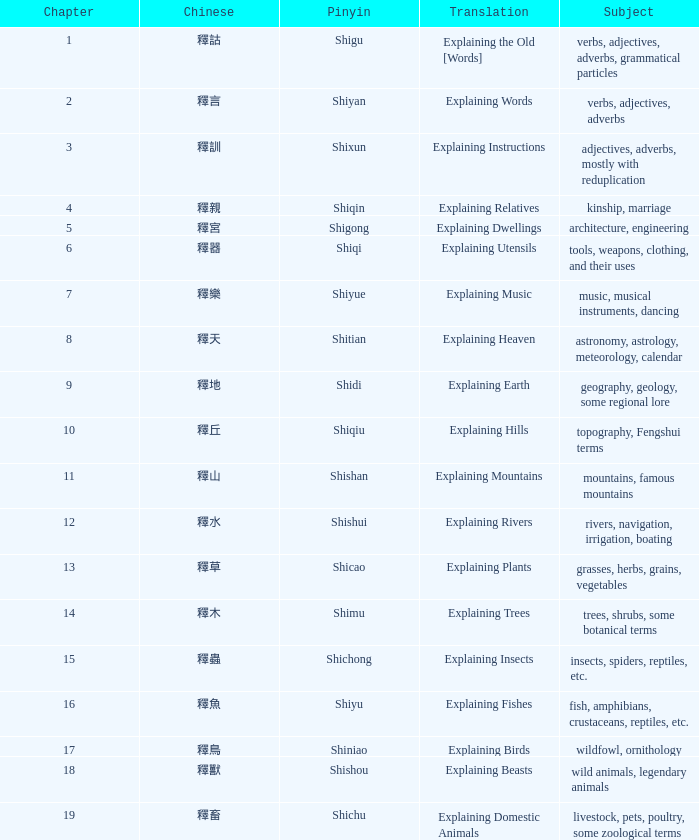Could you parse the entire table? {'header': ['Chapter', 'Chinese', 'Pinyin', 'Translation', 'Subject'], 'rows': [['1', '釋詁', 'Shigu', 'Explaining the Old [Words]', 'verbs, adjectives, adverbs, grammatical particles'], ['2', '釋言', 'Shiyan', 'Explaining Words', 'verbs, adjectives, adverbs'], ['3', '釋訓', 'Shixun', 'Explaining Instructions', 'adjectives, adverbs, mostly with reduplication'], ['4', '釋親', 'Shiqin', 'Explaining Relatives', 'kinship, marriage'], ['5', '釋宮', 'Shigong', 'Explaining Dwellings', 'architecture, engineering'], ['6', '釋器', 'Shiqi', 'Explaining Utensils', 'tools, weapons, clothing, and their uses'], ['7', '釋樂', 'Shiyue', 'Explaining Music', 'music, musical instruments, dancing'], ['8', '釋天', 'Shitian', 'Explaining Heaven', 'astronomy, astrology, meteorology, calendar'], ['9', '釋地', 'Shidi', 'Explaining Earth', 'geography, geology, some regional lore'], ['10', '釋丘', 'Shiqiu', 'Explaining Hills', 'topography, Fengshui terms'], ['11', '釋山', 'Shishan', 'Explaining Mountains', 'mountains, famous mountains'], ['12', '釋水', 'Shishui', 'Explaining Rivers', 'rivers, navigation, irrigation, boating'], ['13', '釋草', 'Shicao', 'Explaining Plants', 'grasses, herbs, grains, vegetables'], ['14', '釋木', 'Shimu', 'Explaining Trees', 'trees, shrubs, some botanical terms'], ['15', '釋蟲', 'Shichong', 'Explaining Insects', 'insects, spiders, reptiles, etc.'], ['16', '釋魚', 'Shiyu', 'Explaining Fishes', 'fish, amphibians, crustaceans, reptiles, etc.'], ['17', '釋鳥', 'Shiniao', 'Explaining Birds', 'wildfowl, ornithology'], ['18', '釋獸', 'Shishou', 'Explaining Beasts', 'wild animals, legendary animals'], ['19', '釋畜', 'Shichu', 'Explaining Domestic Animals', 'livestock, pets, poultry, some zoological terms']]} Name the chapter with chinese of 釋水 12.0. 